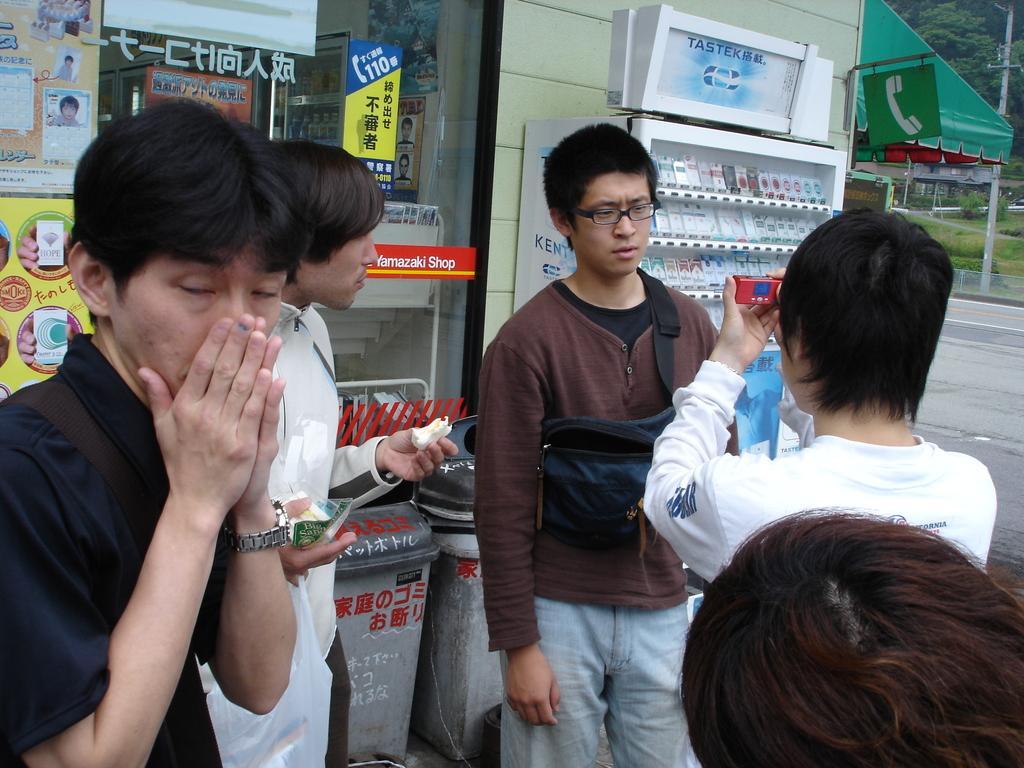How would you summarize this image in a sentence or two? In the front of the image I can see people. Among them two people are holding objects. In the background of the image there are trees, poles, building, store, racks, bins, posters, grass, road and objects.   